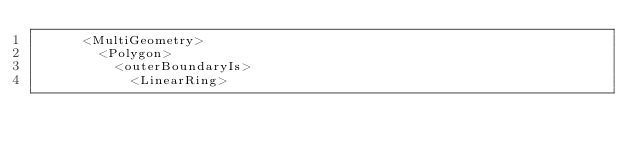Convert code to text. <code><loc_0><loc_0><loc_500><loc_500><_XML_>      <MultiGeometry>
        <Polygon>
          <outerBoundaryIs>
            <LinearRing></code> 